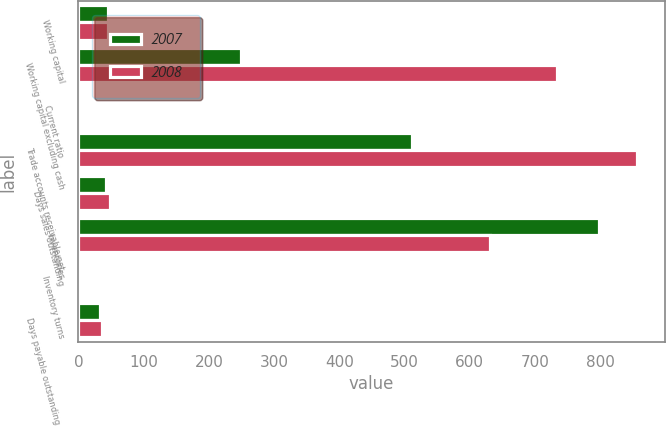<chart> <loc_0><loc_0><loc_500><loc_500><stacked_bar_chart><ecel><fcel>Working capital<fcel>Working capital excluding cash<fcel>Current ratio<fcel>Trade accounts receivable net<fcel>Days sales outstanding<fcel>Inventories<fcel>Inventory turns<fcel>Days payable outstanding (1)<nl><fcel>2007<fcel>46<fcel>249<fcel>2.31<fcel>512<fcel>43<fcel>798<fcel>4.3<fcel>33<nl><fcel>2008<fcel>46<fcel>734<fcel>2.11<fcel>856<fcel>49<fcel>631<fcel>4.7<fcel>36<nl></chart> 